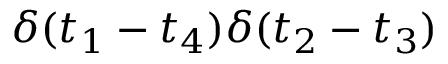Convert formula to latex. <formula><loc_0><loc_0><loc_500><loc_500>\delta ( t _ { 1 } - t _ { 4 } ) \delta ( t _ { 2 } - t _ { 3 } )</formula> 